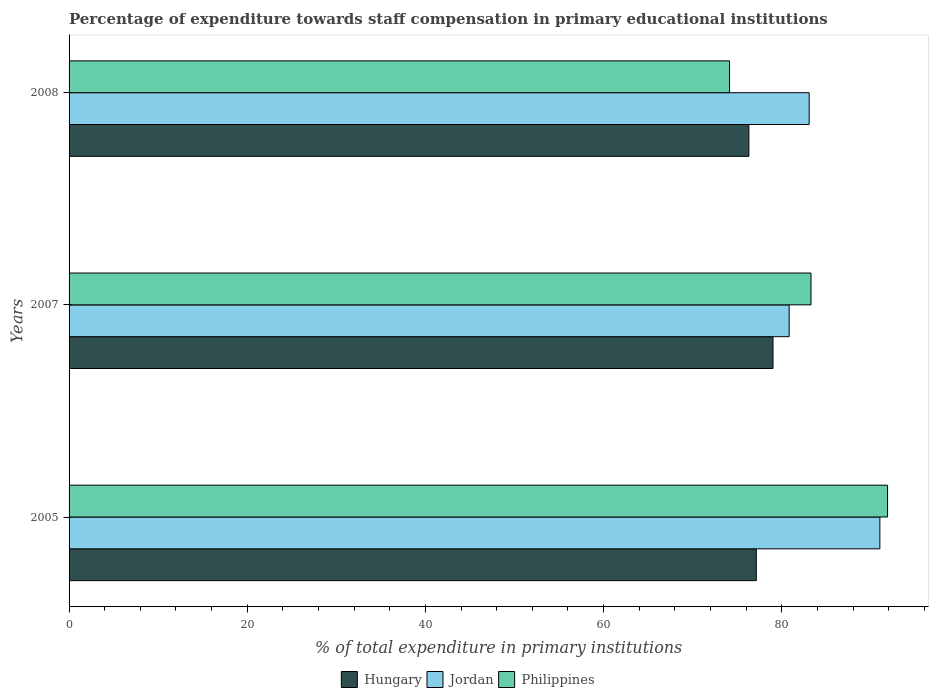Are the number of bars on each tick of the Y-axis equal?
Offer a very short reply. Yes. How many bars are there on the 1st tick from the top?
Your answer should be compact. 3. What is the label of the 1st group of bars from the top?
Your answer should be compact. 2008. What is the percentage of expenditure towards staff compensation in Jordan in 2005?
Your response must be concise. 91.01. Across all years, what is the maximum percentage of expenditure towards staff compensation in Jordan?
Ensure brevity in your answer.  91.01. Across all years, what is the minimum percentage of expenditure towards staff compensation in Jordan?
Make the answer very short. 80.83. What is the total percentage of expenditure towards staff compensation in Jordan in the graph?
Make the answer very short. 254.92. What is the difference between the percentage of expenditure towards staff compensation in Philippines in 2007 and that in 2008?
Provide a short and direct response. 9.14. What is the difference between the percentage of expenditure towards staff compensation in Philippines in 2008 and the percentage of expenditure towards staff compensation in Jordan in 2007?
Provide a short and direct response. -6.69. What is the average percentage of expenditure towards staff compensation in Jordan per year?
Your answer should be very brief. 84.97. In the year 2007, what is the difference between the percentage of expenditure towards staff compensation in Jordan and percentage of expenditure towards staff compensation in Philippines?
Offer a very short reply. -2.45. What is the ratio of the percentage of expenditure towards staff compensation in Hungary in 2005 to that in 2008?
Offer a very short reply. 1.01. What is the difference between the highest and the second highest percentage of expenditure towards staff compensation in Hungary?
Make the answer very short. 1.87. What is the difference between the highest and the lowest percentage of expenditure towards staff compensation in Philippines?
Your answer should be compact. 17.74. In how many years, is the percentage of expenditure towards staff compensation in Jordan greater than the average percentage of expenditure towards staff compensation in Jordan taken over all years?
Make the answer very short. 1. Is the sum of the percentage of expenditure towards staff compensation in Hungary in 2007 and 2008 greater than the maximum percentage of expenditure towards staff compensation in Jordan across all years?
Make the answer very short. Yes. What does the 3rd bar from the top in 2005 represents?
Your response must be concise. Hungary. What does the 3rd bar from the bottom in 2007 represents?
Your answer should be compact. Philippines. How many bars are there?
Your response must be concise. 9. Are all the bars in the graph horizontal?
Offer a very short reply. Yes. What is the difference between two consecutive major ticks on the X-axis?
Provide a short and direct response. 20. Does the graph contain any zero values?
Your response must be concise. No. Does the graph contain grids?
Keep it short and to the point. No. How are the legend labels stacked?
Your answer should be compact. Horizontal. What is the title of the graph?
Your answer should be compact. Percentage of expenditure towards staff compensation in primary educational institutions. What is the label or title of the X-axis?
Provide a succinct answer. % of total expenditure in primary institutions. What is the label or title of the Y-axis?
Offer a terse response. Years. What is the % of total expenditure in primary institutions in Hungary in 2005?
Ensure brevity in your answer.  77.14. What is the % of total expenditure in primary institutions in Jordan in 2005?
Give a very brief answer. 91.01. What is the % of total expenditure in primary institutions of Philippines in 2005?
Your response must be concise. 91.88. What is the % of total expenditure in primary institutions in Hungary in 2007?
Your answer should be compact. 79.01. What is the % of total expenditure in primary institutions in Jordan in 2007?
Provide a short and direct response. 80.83. What is the % of total expenditure in primary institutions of Philippines in 2007?
Offer a very short reply. 83.28. What is the % of total expenditure in primary institutions in Hungary in 2008?
Your response must be concise. 76.31. What is the % of total expenditure in primary institutions in Jordan in 2008?
Your answer should be very brief. 83.08. What is the % of total expenditure in primary institutions in Philippines in 2008?
Ensure brevity in your answer.  74.14. Across all years, what is the maximum % of total expenditure in primary institutions in Hungary?
Ensure brevity in your answer.  79.01. Across all years, what is the maximum % of total expenditure in primary institutions of Jordan?
Make the answer very short. 91.01. Across all years, what is the maximum % of total expenditure in primary institutions in Philippines?
Keep it short and to the point. 91.88. Across all years, what is the minimum % of total expenditure in primary institutions in Hungary?
Make the answer very short. 76.31. Across all years, what is the minimum % of total expenditure in primary institutions in Jordan?
Offer a very short reply. 80.83. Across all years, what is the minimum % of total expenditure in primary institutions of Philippines?
Ensure brevity in your answer.  74.14. What is the total % of total expenditure in primary institutions of Hungary in the graph?
Ensure brevity in your answer.  232.46. What is the total % of total expenditure in primary institutions in Jordan in the graph?
Provide a succinct answer. 254.92. What is the total % of total expenditure in primary institutions of Philippines in the graph?
Provide a short and direct response. 249.29. What is the difference between the % of total expenditure in primary institutions in Hungary in 2005 and that in 2007?
Provide a short and direct response. -1.87. What is the difference between the % of total expenditure in primary institutions of Jordan in 2005 and that in 2007?
Provide a short and direct response. 10.18. What is the difference between the % of total expenditure in primary institutions of Philippines in 2005 and that in 2007?
Provide a short and direct response. 8.59. What is the difference between the % of total expenditure in primary institutions of Hungary in 2005 and that in 2008?
Make the answer very short. 0.83. What is the difference between the % of total expenditure in primary institutions in Jordan in 2005 and that in 2008?
Give a very brief answer. 7.94. What is the difference between the % of total expenditure in primary institutions of Philippines in 2005 and that in 2008?
Provide a short and direct response. 17.74. What is the difference between the % of total expenditure in primary institutions of Hungary in 2007 and that in 2008?
Your answer should be very brief. 2.71. What is the difference between the % of total expenditure in primary institutions in Jordan in 2007 and that in 2008?
Your answer should be compact. -2.25. What is the difference between the % of total expenditure in primary institutions of Philippines in 2007 and that in 2008?
Give a very brief answer. 9.14. What is the difference between the % of total expenditure in primary institutions in Hungary in 2005 and the % of total expenditure in primary institutions in Jordan in 2007?
Your answer should be compact. -3.69. What is the difference between the % of total expenditure in primary institutions of Hungary in 2005 and the % of total expenditure in primary institutions of Philippines in 2007?
Provide a succinct answer. -6.14. What is the difference between the % of total expenditure in primary institutions of Jordan in 2005 and the % of total expenditure in primary institutions of Philippines in 2007?
Make the answer very short. 7.73. What is the difference between the % of total expenditure in primary institutions of Hungary in 2005 and the % of total expenditure in primary institutions of Jordan in 2008?
Your response must be concise. -5.93. What is the difference between the % of total expenditure in primary institutions of Hungary in 2005 and the % of total expenditure in primary institutions of Philippines in 2008?
Your answer should be very brief. 3. What is the difference between the % of total expenditure in primary institutions of Jordan in 2005 and the % of total expenditure in primary institutions of Philippines in 2008?
Offer a very short reply. 16.88. What is the difference between the % of total expenditure in primary institutions in Hungary in 2007 and the % of total expenditure in primary institutions in Jordan in 2008?
Your answer should be very brief. -4.06. What is the difference between the % of total expenditure in primary institutions in Hungary in 2007 and the % of total expenditure in primary institutions in Philippines in 2008?
Provide a short and direct response. 4.88. What is the difference between the % of total expenditure in primary institutions in Jordan in 2007 and the % of total expenditure in primary institutions in Philippines in 2008?
Keep it short and to the point. 6.69. What is the average % of total expenditure in primary institutions of Hungary per year?
Keep it short and to the point. 77.49. What is the average % of total expenditure in primary institutions of Jordan per year?
Your answer should be compact. 84.97. What is the average % of total expenditure in primary institutions in Philippines per year?
Keep it short and to the point. 83.1. In the year 2005, what is the difference between the % of total expenditure in primary institutions of Hungary and % of total expenditure in primary institutions of Jordan?
Your response must be concise. -13.87. In the year 2005, what is the difference between the % of total expenditure in primary institutions in Hungary and % of total expenditure in primary institutions in Philippines?
Your response must be concise. -14.73. In the year 2005, what is the difference between the % of total expenditure in primary institutions of Jordan and % of total expenditure in primary institutions of Philippines?
Offer a terse response. -0.86. In the year 2007, what is the difference between the % of total expenditure in primary institutions in Hungary and % of total expenditure in primary institutions in Jordan?
Your answer should be compact. -1.81. In the year 2007, what is the difference between the % of total expenditure in primary institutions of Hungary and % of total expenditure in primary institutions of Philippines?
Provide a succinct answer. -4.27. In the year 2007, what is the difference between the % of total expenditure in primary institutions of Jordan and % of total expenditure in primary institutions of Philippines?
Your answer should be very brief. -2.45. In the year 2008, what is the difference between the % of total expenditure in primary institutions in Hungary and % of total expenditure in primary institutions in Jordan?
Your answer should be very brief. -6.77. In the year 2008, what is the difference between the % of total expenditure in primary institutions of Hungary and % of total expenditure in primary institutions of Philippines?
Give a very brief answer. 2.17. In the year 2008, what is the difference between the % of total expenditure in primary institutions in Jordan and % of total expenditure in primary institutions in Philippines?
Provide a succinct answer. 8.94. What is the ratio of the % of total expenditure in primary institutions of Hungary in 2005 to that in 2007?
Your answer should be compact. 0.98. What is the ratio of the % of total expenditure in primary institutions of Jordan in 2005 to that in 2007?
Provide a succinct answer. 1.13. What is the ratio of the % of total expenditure in primary institutions in Philippines in 2005 to that in 2007?
Offer a terse response. 1.1. What is the ratio of the % of total expenditure in primary institutions of Hungary in 2005 to that in 2008?
Provide a short and direct response. 1.01. What is the ratio of the % of total expenditure in primary institutions in Jordan in 2005 to that in 2008?
Your answer should be compact. 1.1. What is the ratio of the % of total expenditure in primary institutions of Philippines in 2005 to that in 2008?
Ensure brevity in your answer.  1.24. What is the ratio of the % of total expenditure in primary institutions of Hungary in 2007 to that in 2008?
Make the answer very short. 1.04. What is the ratio of the % of total expenditure in primary institutions in Philippines in 2007 to that in 2008?
Keep it short and to the point. 1.12. What is the difference between the highest and the second highest % of total expenditure in primary institutions of Hungary?
Offer a very short reply. 1.87. What is the difference between the highest and the second highest % of total expenditure in primary institutions in Jordan?
Your response must be concise. 7.94. What is the difference between the highest and the second highest % of total expenditure in primary institutions of Philippines?
Make the answer very short. 8.59. What is the difference between the highest and the lowest % of total expenditure in primary institutions of Hungary?
Offer a terse response. 2.71. What is the difference between the highest and the lowest % of total expenditure in primary institutions of Jordan?
Offer a terse response. 10.18. What is the difference between the highest and the lowest % of total expenditure in primary institutions of Philippines?
Provide a succinct answer. 17.74. 